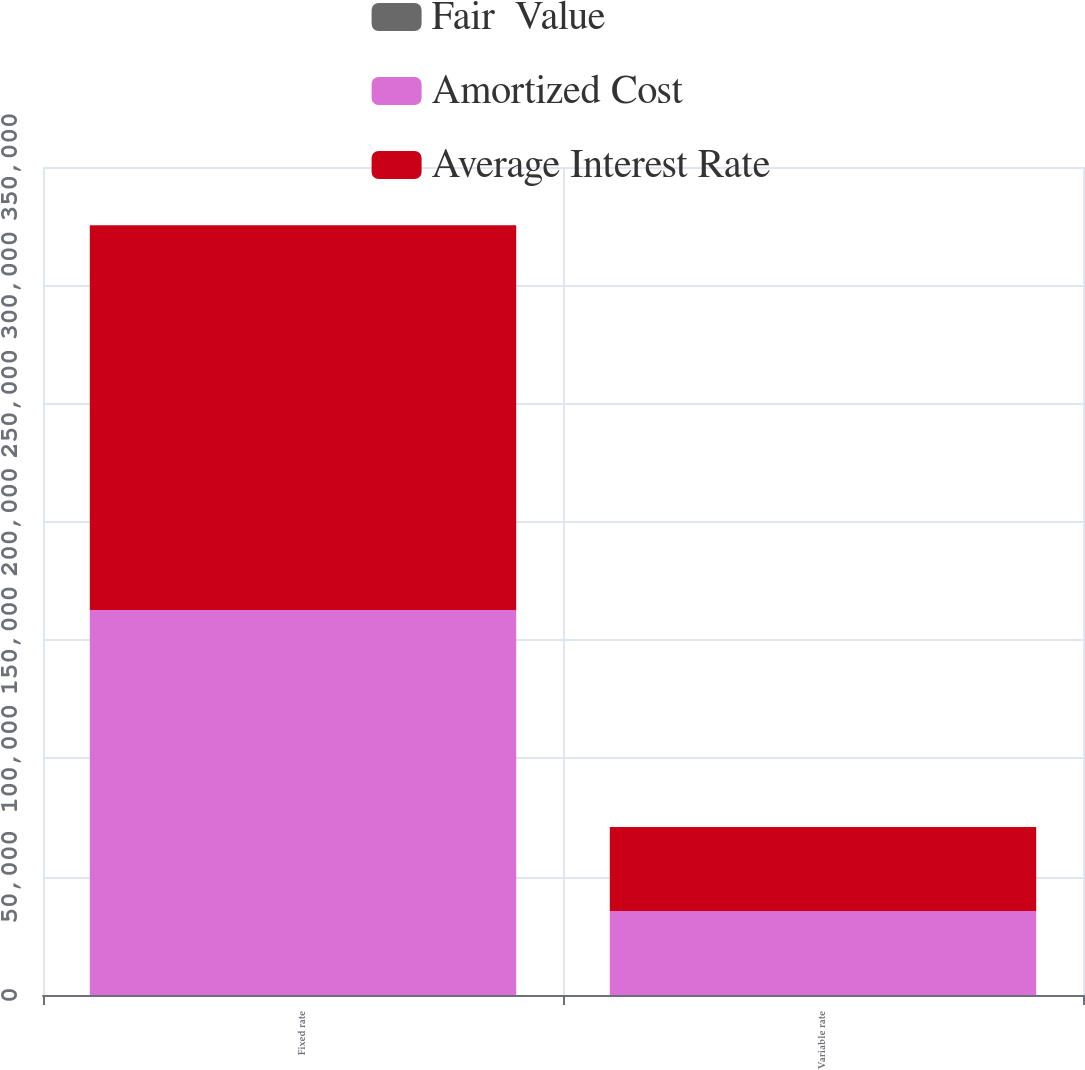Convert chart to OTSL. <chart><loc_0><loc_0><loc_500><loc_500><stacked_bar_chart><ecel><fcel>Fixed rate<fcel>Variable rate<nl><fcel>Fair  Value<fcel>1.35<fcel>1.21<nl><fcel>Amortized Cost<fcel>162699<fcel>35507<nl><fcel>Average Interest Rate<fcel>162699<fcel>35507<nl></chart> 